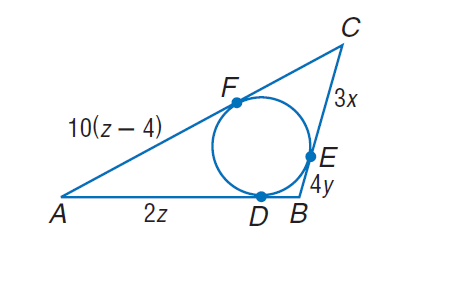Answer the mathemtical geometry problem and directly provide the correct option letter.
Question: Find the perimeter of the polygon for the given information. C F = 6(3 - x), D B = 12 y - 4.
Choices: A: 36 B: 72 C: 90 D: 108 A 